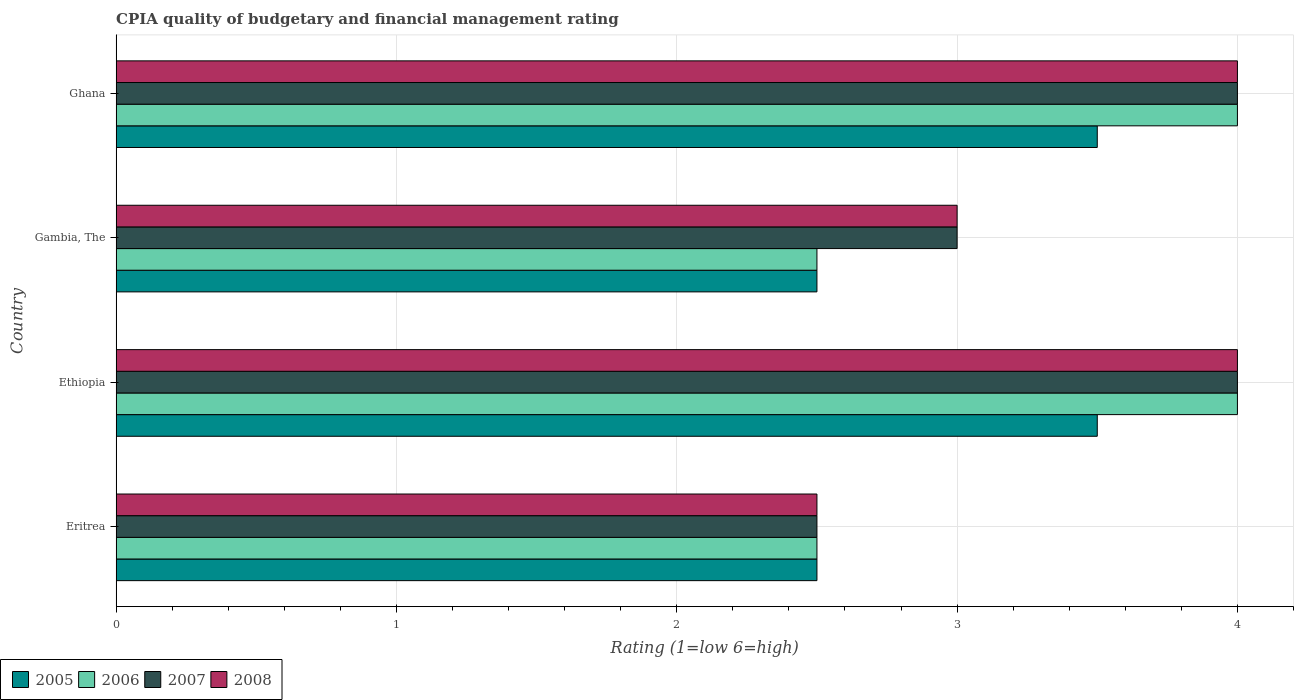How many different coloured bars are there?
Ensure brevity in your answer.  4. Are the number of bars on each tick of the Y-axis equal?
Keep it short and to the point. Yes. How many bars are there on the 4th tick from the top?
Provide a short and direct response. 4. How many bars are there on the 4th tick from the bottom?
Your answer should be compact. 4. In how many cases, is the number of bars for a given country not equal to the number of legend labels?
Provide a succinct answer. 0. Across all countries, what is the maximum CPIA rating in 2005?
Make the answer very short. 3.5. Across all countries, what is the minimum CPIA rating in 2005?
Your response must be concise. 2.5. In which country was the CPIA rating in 2007 maximum?
Provide a short and direct response. Ethiopia. In which country was the CPIA rating in 2005 minimum?
Your answer should be compact. Eritrea. What is the difference between the CPIA rating in 2006 in Ethiopia and that in Ghana?
Provide a short and direct response. 0. What is the difference between the CPIA rating in 2007 in Ghana and the CPIA rating in 2005 in Gambia, The?
Offer a terse response. 1.5. What is the average CPIA rating in 2005 per country?
Offer a very short reply. 3. In how many countries, is the CPIA rating in 2008 greater than 2.6 ?
Provide a succinct answer. 3. Is the CPIA rating in 2007 in Ethiopia less than that in Ghana?
Provide a succinct answer. No. Is the difference between the CPIA rating in 2008 in Ethiopia and Ghana greater than the difference between the CPIA rating in 2007 in Ethiopia and Ghana?
Give a very brief answer. No. What is the difference between the highest and the lowest CPIA rating in 2008?
Provide a succinct answer. 1.5. In how many countries, is the CPIA rating in 2008 greater than the average CPIA rating in 2008 taken over all countries?
Your response must be concise. 2. Is the sum of the CPIA rating in 2007 in Eritrea and Gambia, The greater than the maximum CPIA rating in 2008 across all countries?
Your response must be concise. Yes. What does the 4th bar from the bottom in Ethiopia represents?
Make the answer very short. 2008. Is it the case that in every country, the sum of the CPIA rating in 2008 and CPIA rating in 2006 is greater than the CPIA rating in 2005?
Make the answer very short. Yes. How many countries are there in the graph?
Your answer should be very brief. 4. Does the graph contain grids?
Your response must be concise. Yes. How many legend labels are there?
Ensure brevity in your answer.  4. What is the title of the graph?
Your response must be concise. CPIA quality of budgetary and financial management rating. Does "1965" appear as one of the legend labels in the graph?
Your answer should be very brief. No. What is the Rating (1=low 6=high) of 2006 in Eritrea?
Offer a terse response. 2.5. What is the Rating (1=low 6=high) in 2007 in Eritrea?
Offer a very short reply. 2.5. What is the Rating (1=low 6=high) of 2008 in Eritrea?
Give a very brief answer. 2.5. What is the Rating (1=low 6=high) of 2005 in Ethiopia?
Give a very brief answer. 3.5. What is the Rating (1=low 6=high) of 2007 in Ghana?
Provide a short and direct response. 4. Across all countries, what is the maximum Rating (1=low 6=high) in 2007?
Offer a terse response. 4. Across all countries, what is the maximum Rating (1=low 6=high) of 2008?
Offer a very short reply. 4. Across all countries, what is the minimum Rating (1=low 6=high) of 2005?
Provide a succinct answer. 2.5. Across all countries, what is the minimum Rating (1=low 6=high) in 2006?
Your response must be concise. 2.5. What is the total Rating (1=low 6=high) in 2007 in the graph?
Offer a very short reply. 13.5. What is the difference between the Rating (1=low 6=high) in 2007 in Eritrea and that in Ethiopia?
Give a very brief answer. -1.5. What is the difference between the Rating (1=low 6=high) in 2008 in Eritrea and that in Ethiopia?
Offer a very short reply. -1.5. What is the difference between the Rating (1=low 6=high) of 2005 in Eritrea and that in Gambia, The?
Offer a terse response. 0. What is the difference between the Rating (1=low 6=high) of 2007 in Eritrea and that in Gambia, The?
Ensure brevity in your answer.  -0.5. What is the difference between the Rating (1=low 6=high) in 2008 in Eritrea and that in Gambia, The?
Provide a short and direct response. -0.5. What is the difference between the Rating (1=low 6=high) in 2006 in Eritrea and that in Ghana?
Your answer should be compact. -1.5. What is the difference between the Rating (1=low 6=high) of 2005 in Ethiopia and that in Gambia, The?
Make the answer very short. 1. What is the difference between the Rating (1=low 6=high) of 2007 in Ethiopia and that in Gambia, The?
Your answer should be very brief. 1. What is the difference between the Rating (1=low 6=high) in 2005 in Ethiopia and that in Ghana?
Give a very brief answer. 0. What is the difference between the Rating (1=low 6=high) in 2006 in Ethiopia and that in Ghana?
Your response must be concise. 0. What is the difference between the Rating (1=low 6=high) of 2008 in Ethiopia and that in Ghana?
Your response must be concise. 0. What is the difference between the Rating (1=low 6=high) in 2005 in Gambia, The and that in Ghana?
Keep it short and to the point. -1. What is the difference between the Rating (1=low 6=high) in 2006 in Gambia, The and that in Ghana?
Your answer should be compact. -1.5. What is the difference between the Rating (1=low 6=high) in 2008 in Gambia, The and that in Ghana?
Give a very brief answer. -1. What is the difference between the Rating (1=low 6=high) of 2005 in Eritrea and the Rating (1=low 6=high) of 2007 in Ethiopia?
Make the answer very short. -1.5. What is the difference between the Rating (1=low 6=high) in 2006 in Eritrea and the Rating (1=low 6=high) in 2007 in Ethiopia?
Provide a short and direct response. -1.5. What is the difference between the Rating (1=low 6=high) in 2006 in Eritrea and the Rating (1=low 6=high) in 2008 in Ethiopia?
Provide a succinct answer. -1.5. What is the difference between the Rating (1=low 6=high) of 2007 in Eritrea and the Rating (1=low 6=high) of 2008 in Gambia, The?
Your response must be concise. -0.5. What is the difference between the Rating (1=low 6=high) of 2005 in Eritrea and the Rating (1=low 6=high) of 2006 in Ghana?
Give a very brief answer. -1.5. What is the difference between the Rating (1=low 6=high) in 2005 in Eritrea and the Rating (1=low 6=high) in 2007 in Ghana?
Give a very brief answer. -1.5. What is the difference between the Rating (1=low 6=high) in 2005 in Eritrea and the Rating (1=low 6=high) in 2008 in Ghana?
Provide a short and direct response. -1.5. What is the difference between the Rating (1=low 6=high) in 2006 in Eritrea and the Rating (1=low 6=high) in 2008 in Ghana?
Your response must be concise. -1.5. What is the difference between the Rating (1=low 6=high) of 2006 in Ethiopia and the Rating (1=low 6=high) of 2007 in Gambia, The?
Provide a succinct answer. 1. What is the difference between the Rating (1=low 6=high) of 2007 in Ethiopia and the Rating (1=low 6=high) of 2008 in Gambia, The?
Provide a short and direct response. 1. What is the difference between the Rating (1=low 6=high) of 2005 in Ethiopia and the Rating (1=low 6=high) of 2008 in Ghana?
Give a very brief answer. -0.5. What is the difference between the Rating (1=low 6=high) in 2007 in Ethiopia and the Rating (1=low 6=high) in 2008 in Ghana?
Provide a succinct answer. 0. What is the difference between the Rating (1=low 6=high) of 2005 in Gambia, The and the Rating (1=low 6=high) of 2006 in Ghana?
Your answer should be compact. -1.5. What is the difference between the Rating (1=low 6=high) in 2005 in Gambia, The and the Rating (1=low 6=high) in 2008 in Ghana?
Provide a succinct answer. -1.5. What is the difference between the Rating (1=low 6=high) of 2006 in Gambia, The and the Rating (1=low 6=high) of 2007 in Ghana?
Your answer should be very brief. -1.5. What is the average Rating (1=low 6=high) of 2005 per country?
Keep it short and to the point. 3. What is the average Rating (1=low 6=high) in 2006 per country?
Offer a very short reply. 3.25. What is the average Rating (1=low 6=high) of 2007 per country?
Provide a short and direct response. 3.38. What is the average Rating (1=low 6=high) of 2008 per country?
Your answer should be compact. 3.38. What is the difference between the Rating (1=low 6=high) of 2005 and Rating (1=low 6=high) of 2008 in Eritrea?
Your answer should be compact. 0. What is the difference between the Rating (1=low 6=high) in 2006 and Rating (1=low 6=high) in 2008 in Eritrea?
Ensure brevity in your answer.  0. What is the difference between the Rating (1=low 6=high) in 2007 and Rating (1=low 6=high) in 2008 in Eritrea?
Offer a very short reply. 0. What is the difference between the Rating (1=low 6=high) of 2005 and Rating (1=low 6=high) of 2007 in Ethiopia?
Provide a succinct answer. -0.5. What is the difference between the Rating (1=low 6=high) of 2005 and Rating (1=low 6=high) of 2008 in Ethiopia?
Provide a succinct answer. -0.5. What is the difference between the Rating (1=low 6=high) in 2006 and Rating (1=low 6=high) in 2007 in Ethiopia?
Keep it short and to the point. 0. What is the difference between the Rating (1=low 6=high) of 2005 and Rating (1=low 6=high) of 2006 in Gambia, The?
Your answer should be very brief. 0. What is the difference between the Rating (1=low 6=high) in 2005 and Rating (1=low 6=high) in 2007 in Gambia, The?
Ensure brevity in your answer.  -0.5. What is the difference between the Rating (1=low 6=high) in 2006 and Rating (1=low 6=high) in 2007 in Gambia, The?
Make the answer very short. -0.5. What is the difference between the Rating (1=low 6=high) of 2005 and Rating (1=low 6=high) of 2006 in Ghana?
Provide a short and direct response. -0.5. What is the difference between the Rating (1=low 6=high) of 2005 and Rating (1=low 6=high) of 2008 in Ghana?
Your answer should be compact. -0.5. What is the difference between the Rating (1=low 6=high) in 2006 and Rating (1=low 6=high) in 2007 in Ghana?
Offer a very short reply. 0. What is the difference between the Rating (1=low 6=high) in 2006 and Rating (1=low 6=high) in 2008 in Ghana?
Ensure brevity in your answer.  0. What is the ratio of the Rating (1=low 6=high) of 2005 in Eritrea to that in Gambia, The?
Provide a succinct answer. 1. What is the ratio of the Rating (1=low 6=high) in 2008 in Eritrea to that in Gambia, The?
Your answer should be compact. 0.83. What is the ratio of the Rating (1=low 6=high) in 2007 in Eritrea to that in Ghana?
Your answer should be compact. 0.62. What is the ratio of the Rating (1=low 6=high) in 2008 in Eritrea to that in Ghana?
Give a very brief answer. 0.62. What is the ratio of the Rating (1=low 6=high) of 2005 in Ethiopia to that in Gambia, The?
Ensure brevity in your answer.  1.4. What is the ratio of the Rating (1=low 6=high) of 2007 in Ethiopia to that in Gambia, The?
Ensure brevity in your answer.  1.33. What is the ratio of the Rating (1=low 6=high) of 2008 in Ethiopia to that in Gambia, The?
Ensure brevity in your answer.  1.33. What is the ratio of the Rating (1=low 6=high) of 2005 in Ethiopia to that in Ghana?
Keep it short and to the point. 1. What is the ratio of the Rating (1=low 6=high) of 2006 in Ethiopia to that in Ghana?
Ensure brevity in your answer.  1. What is the ratio of the Rating (1=low 6=high) of 2008 in Ethiopia to that in Ghana?
Offer a very short reply. 1. What is the ratio of the Rating (1=low 6=high) in 2007 in Gambia, The to that in Ghana?
Your answer should be compact. 0.75. What is the ratio of the Rating (1=low 6=high) in 2008 in Gambia, The to that in Ghana?
Ensure brevity in your answer.  0.75. What is the difference between the highest and the second highest Rating (1=low 6=high) in 2005?
Your answer should be compact. 0. What is the difference between the highest and the second highest Rating (1=low 6=high) in 2007?
Provide a short and direct response. 0. What is the difference between the highest and the lowest Rating (1=low 6=high) in 2006?
Keep it short and to the point. 1.5. What is the difference between the highest and the lowest Rating (1=low 6=high) in 2008?
Your response must be concise. 1.5. 